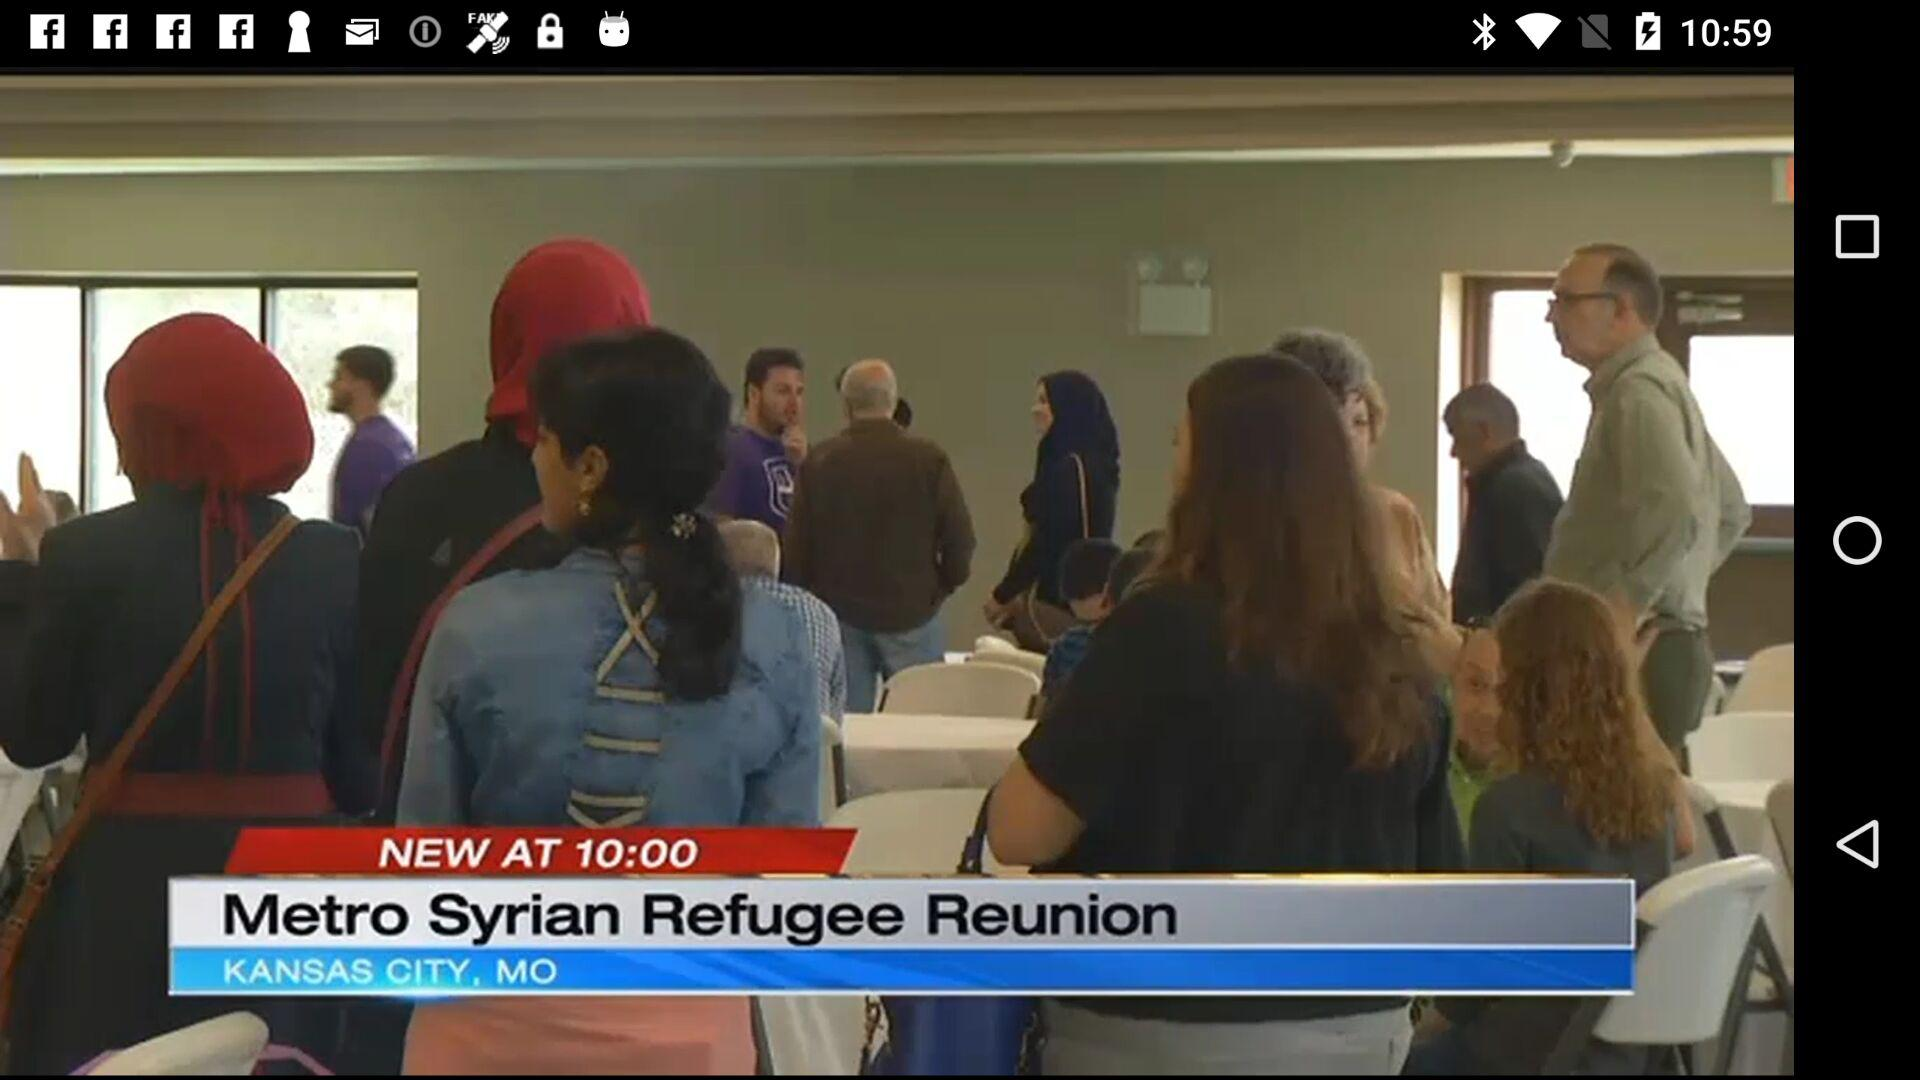What is the status of the "Push Notifications"? The status of the "Push Notifications" is "on". 